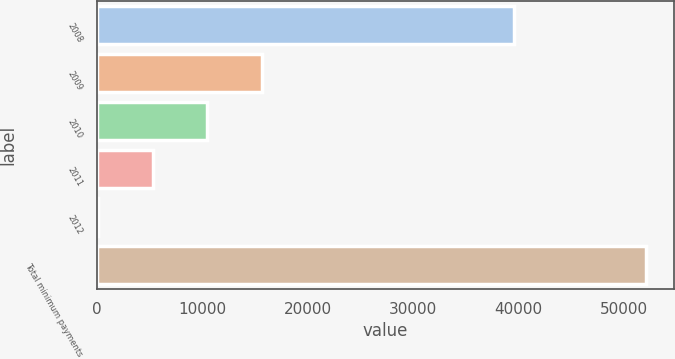Convert chart to OTSL. <chart><loc_0><loc_0><loc_500><loc_500><bar_chart><fcel>2008<fcel>2009<fcel>2010<fcel>2011<fcel>2012<fcel>Total minimum payments<nl><fcel>39577<fcel>15669.7<fcel>10460.8<fcel>5251.9<fcel>43<fcel>52132<nl></chart> 